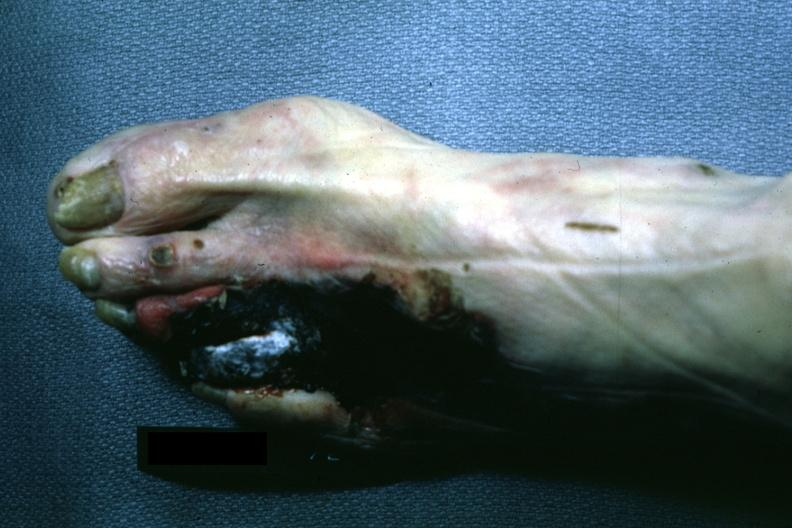does this image show well demarcated gangrene third and fourth toes?
Answer the question using a single word or phrase. Yes 